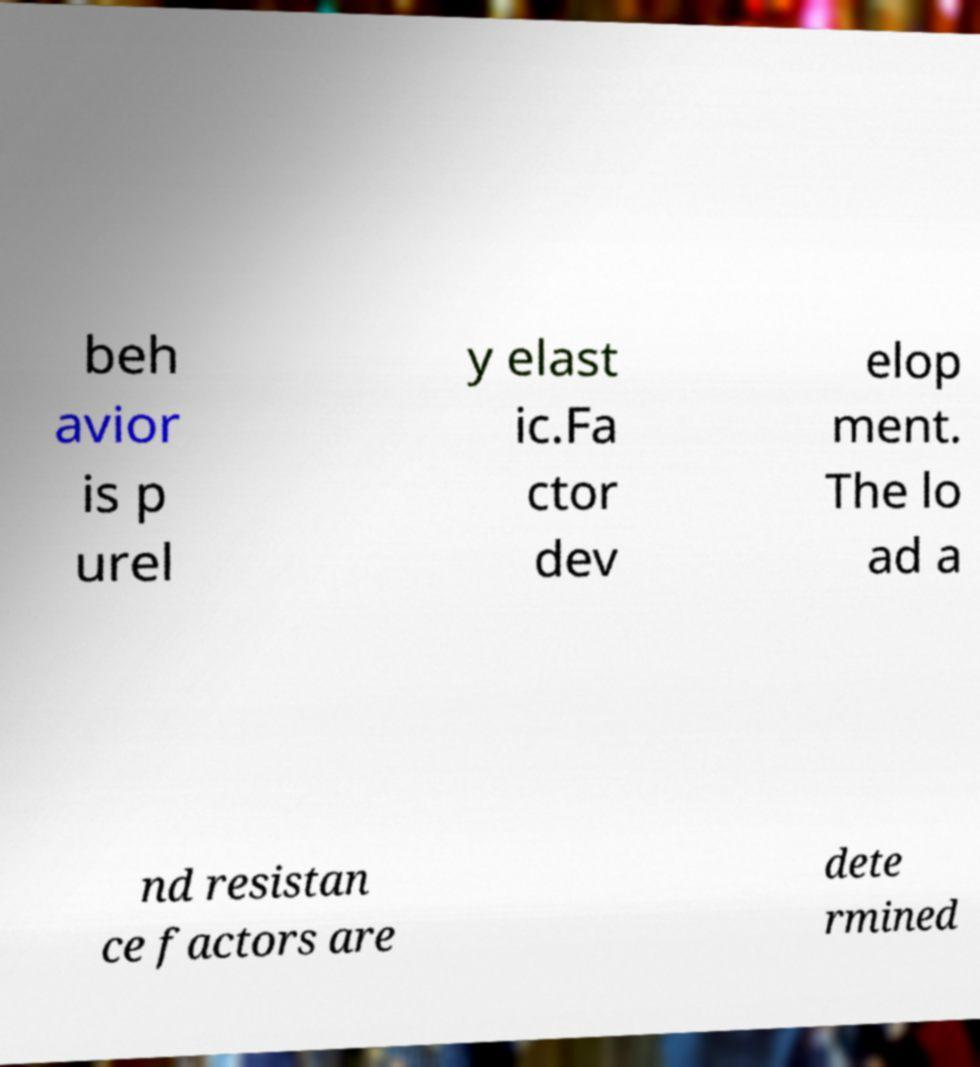For documentation purposes, I need the text within this image transcribed. Could you provide that? beh avior is p urel y elast ic.Fa ctor dev elop ment. The lo ad a nd resistan ce factors are dete rmined 